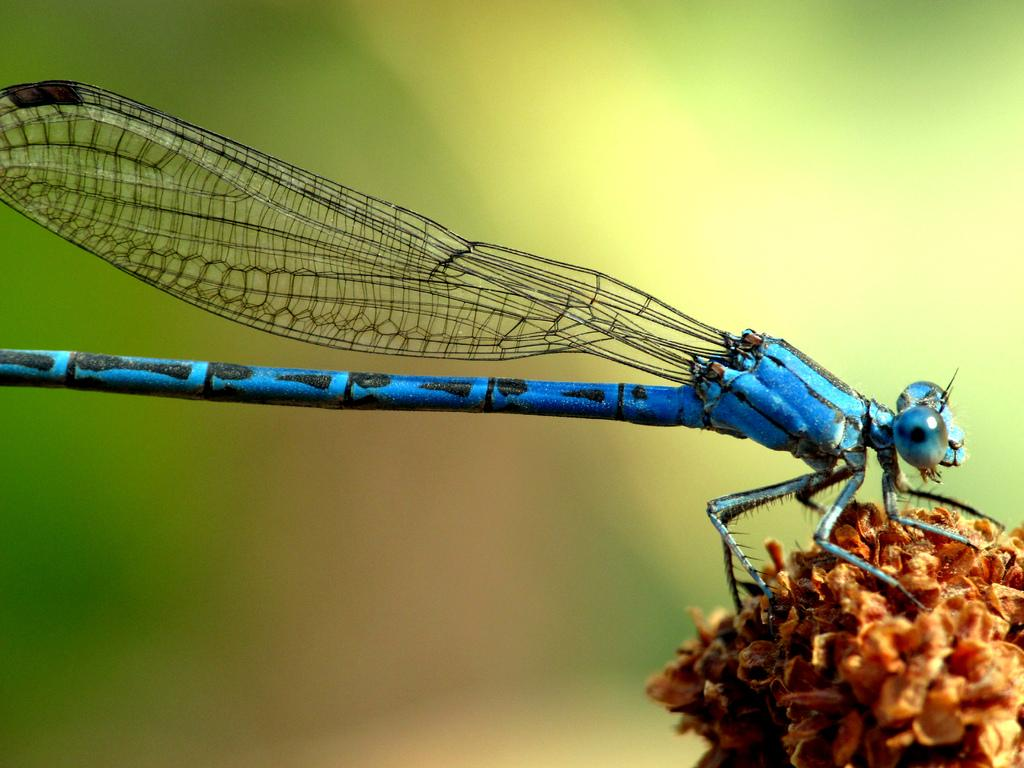What type of creature is in the image? There is a blue insect in the image. Can you describe the background of the image? The background of the image is blurred. What type of cracker is the blue insect holding in the image? There is no cracker present in the image, and the blue insect is not holding anything. 